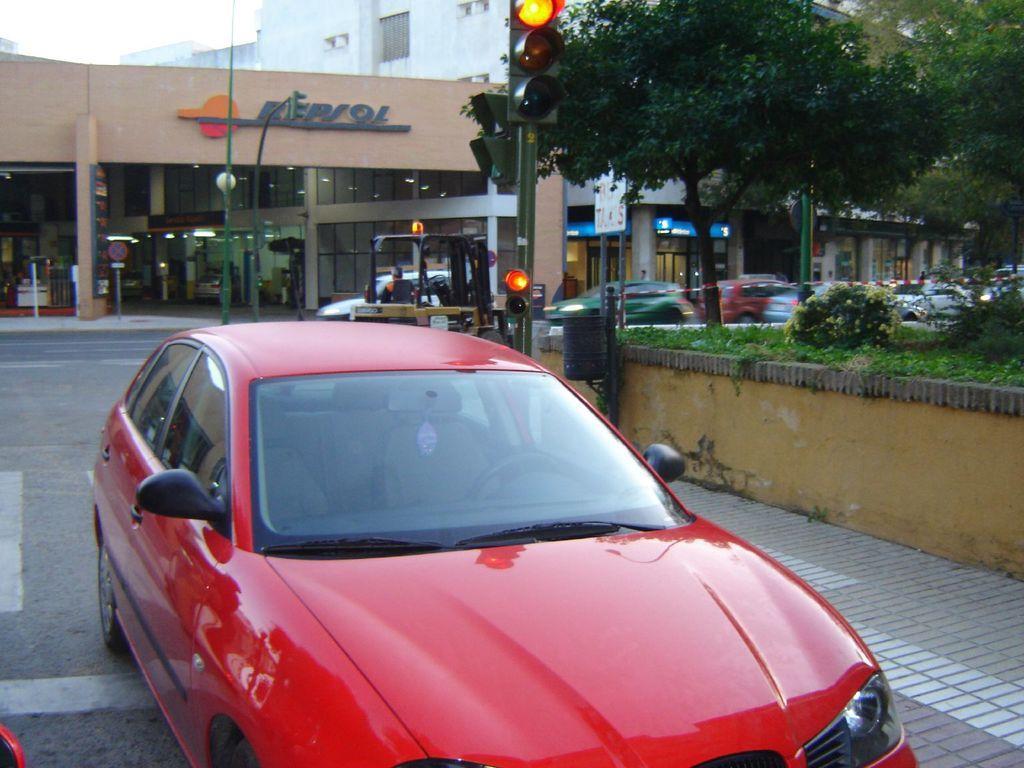Could you give a brief overview of what you see in this image? In the foreground of this picture, there is a red color moving on the road. In the background, we can see plants, grass, trees, building, traffic signal pole, street light and the sky,. 